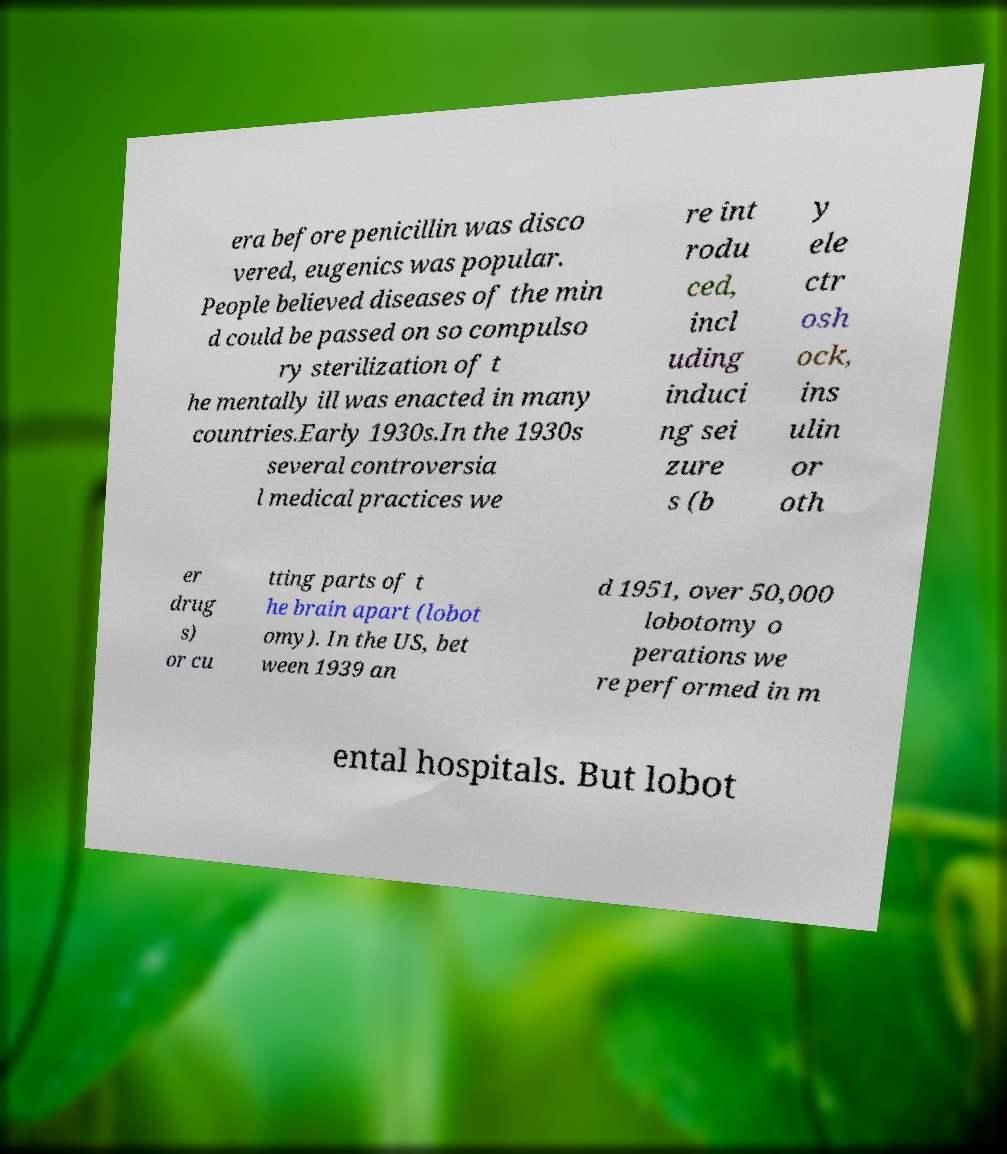Please read and relay the text visible in this image. What does it say? era before penicillin was disco vered, eugenics was popular. People believed diseases of the min d could be passed on so compulso ry sterilization of t he mentally ill was enacted in many countries.Early 1930s.In the 1930s several controversia l medical practices we re int rodu ced, incl uding induci ng sei zure s (b y ele ctr osh ock, ins ulin or oth er drug s) or cu tting parts of t he brain apart (lobot omy). In the US, bet ween 1939 an d 1951, over 50,000 lobotomy o perations we re performed in m ental hospitals. But lobot 